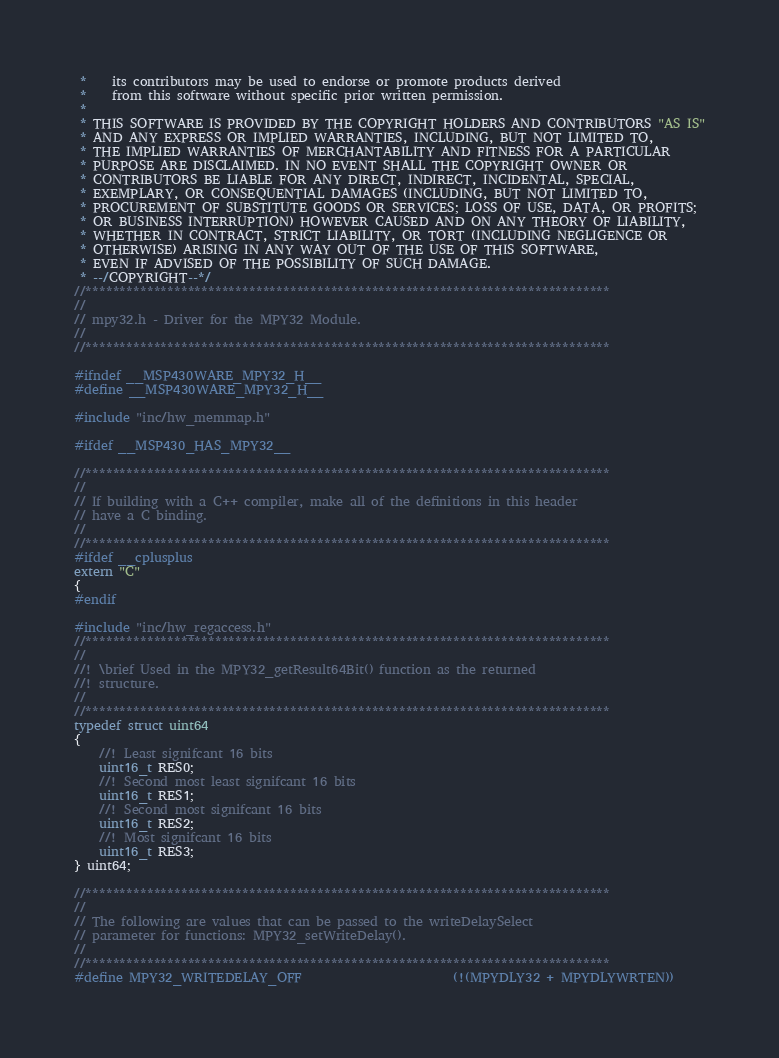<code> <loc_0><loc_0><loc_500><loc_500><_C_> *    its contributors may be used to endorse or promote products derived
 *    from this software without specific prior written permission.
 *
 * THIS SOFTWARE IS PROVIDED BY THE COPYRIGHT HOLDERS AND CONTRIBUTORS "AS IS"
 * AND ANY EXPRESS OR IMPLIED WARRANTIES, INCLUDING, BUT NOT LIMITED TO,
 * THE IMPLIED WARRANTIES OF MERCHANTABILITY AND FITNESS FOR A PARTICULAR
 * PURPOSE ARE DISCLAIMED. IN NO EVENT SHALL THE COPYRIGHT OWNER OR
 * CONTRIBUTORS BE LIABLE FOR ANY DIRECT, INDIRECT, INCIDENTAL, SPECIAL,
 * EXEMPLARY, OR CONSEQUENTIAL DAMAGES (INCLUDING, BUT NOT LIMITED TO,
 * PROCUREMENT OF SUBSTITUTE GOODS OR SERVICES; LOSS OF USE, DATA, OR PROFITS;
 * OR BUSINESS INTERRUPTION) HOWEVER CAUSED AND ON ANY THEORY OF LIABILITY,
 * WHETHER IN CONTRACT, STRICT LIABILITY, OR TORT (INCLUDING NEGLIGENCE OR
 * OTHERWISE) ARISING IN ANY WAY OUT OF THE USE OF THIS SOFTWARE,
 * EVEN IF ADVISED OF THE POSSIBILITY OF SUCH DAMAGE.
 * --/COPYRIGHT--*/
//*****************************************************************************
//
// mpy32.h - Driver for the MPY32 Module.
//
//*****************************************************************************

#ifndef __MSP430WARE_MPY32_H__
#define __MSP430WARE_MPY32_H__

#include "inc/hw_memmap.h"

#ifdef __MSP430_HAS_MPY32__

//*****************************************************************************
//
// If building with a C++ compiler, make all of the definitions in this header
// have a C binding.
//
//*****************************************************************************
#ifdef __cplusplus
extern "C"
{
#endif

#include "inc/hw_regaccess.h"
//*****************************************************************************
//
//! \brief Used in the MPY32_getResult64Bit() function as the returned
//! structure.
//
//*****************************************************************************
typedef struct uint64
{
    //! Least signifcant 16 bits
    uint16_t RES0;
    //! Second most least signifcant 16 bits
    uint16_t RES1;
    //! Second most signifcant 16 bits
    uint16_t RES2;
    //! Most signifcant 16 bits
    uint16_t RES3;
} uint64;

//*****************************************************************************
//
// The following are values that can be passed to the writeDelaySelect
// parameter for functions: MPY32_setWriteDelay().
//
//*****************************************************************************
#define MPY32_WRITEDELAY_OFF                        (!(MPYDLY32 + MPYDLYWRTEN))</code> 